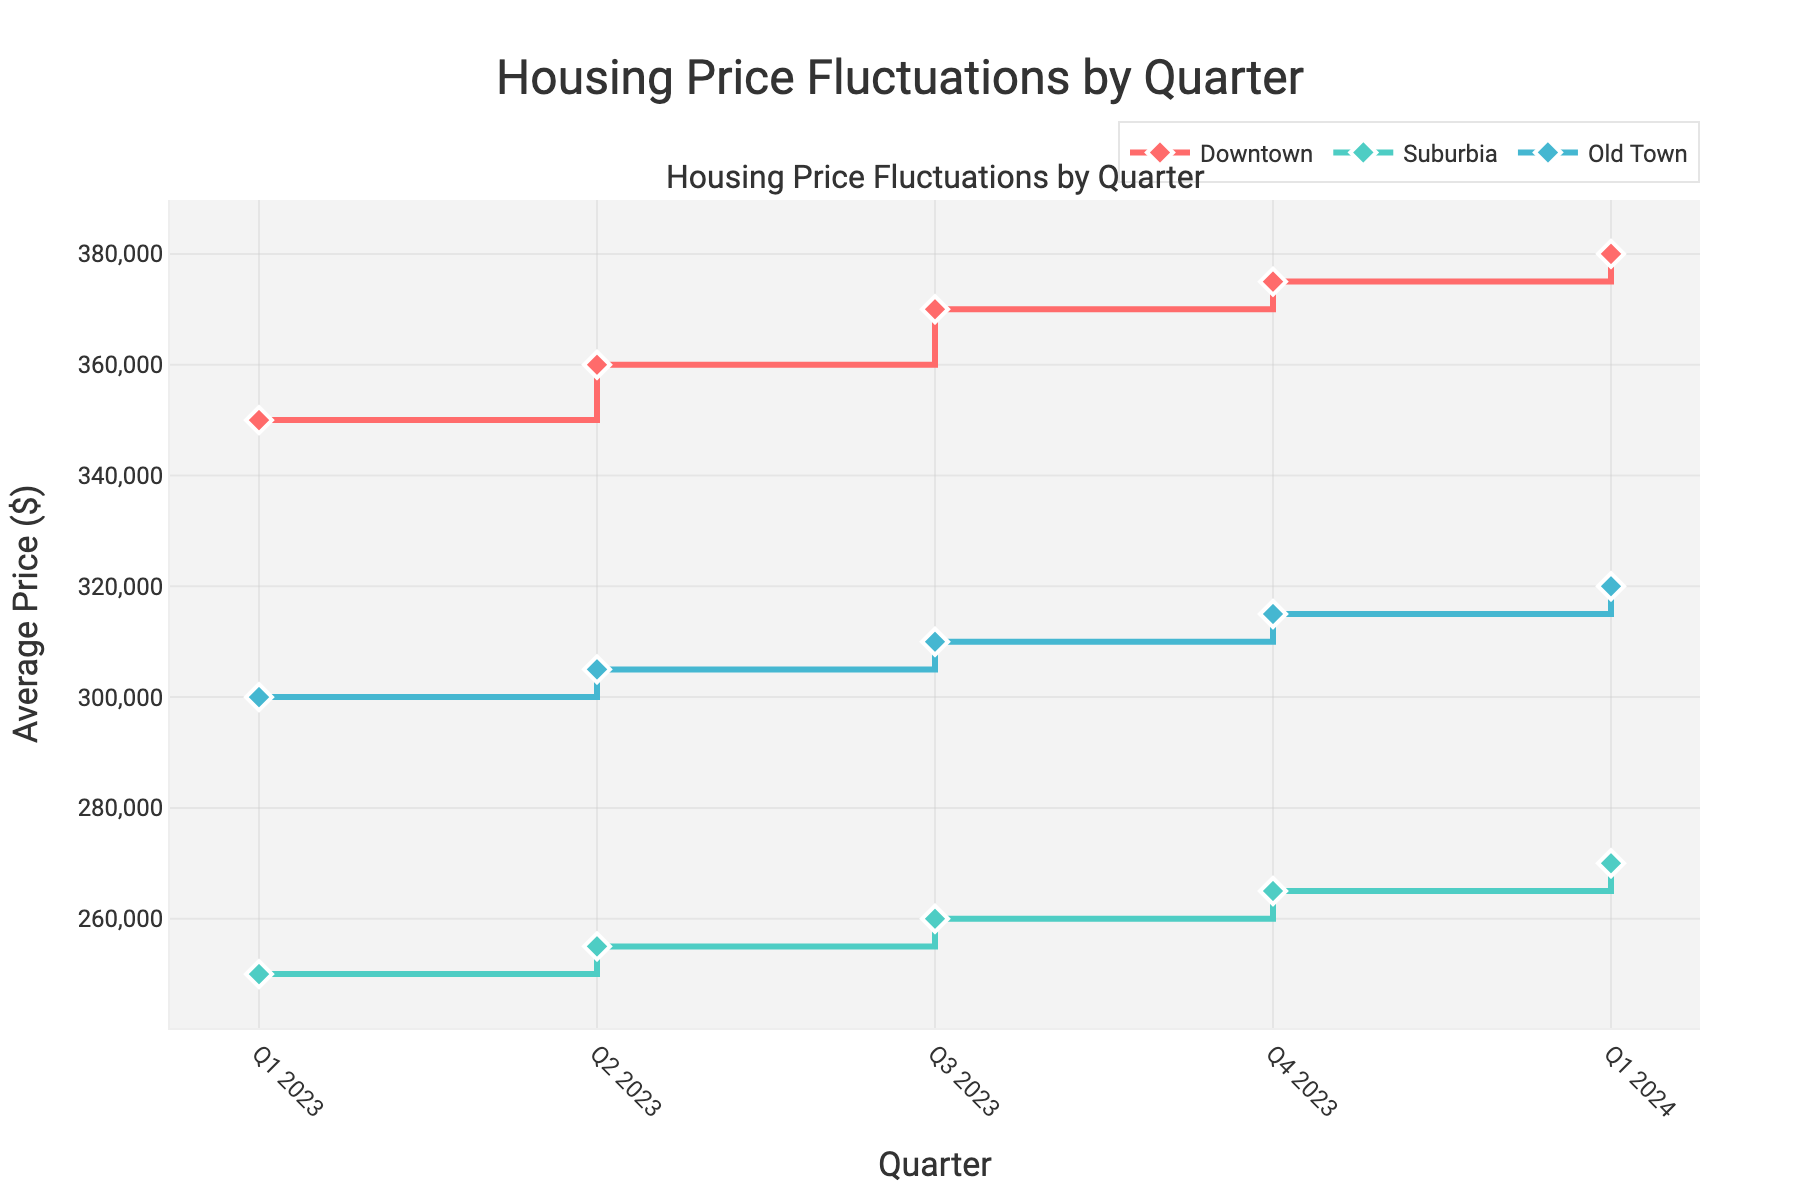What is the title of the plot? The title is displayed at the top of the plot, centered and highlighted for easy identification. The title text reads "Housing Price Fluctuations by Quarter."
Answer: Housing Price Fluctuations by Quarter What are the neighborhoods represented in the plot? The plot uses different lines and markers to represent distinct neighborhoods. The legend at the top of the plot identifies the neighborhoods by their colors and patterns. The neighborhoods are Downtown, Suburbia, and Old Town.
Answer: Downtown, Suburbia, Old Town What is the average housing price in Downtown in Q1 2023? Locate the line corresponding to Downtown and find the data point for Q1 2023. The y-axis value at that point represents the average housing price. For Downtown in Q1 2023, the average price is shown as $350,000.
Answer: $350,000 How did the average price in Suburbia change from Q1 2023 to Q4 2023? Observe the Suburbia line from Q1 2023 to Q4 2023. The y-axis values indicate the prices. Suburbia's average price increased from $250,000 in Q1 2023 to $265,000 in Q4 2023. The change is $265,000 - $250,000.
Answer: $15,000 increase Which neighborhood experienced the highest average price increase from Q1 2023 to Q1 2024? Compare the lines for Downtown, Suburbia, and Old Town over the quarters. Calculate the difference from Q1 2023 to Q1 2024 for each: Downtown ($380,000 - $350,000 = $30,000), Suburbia ($270,000 - $250,000 = $20,000), and Old Town ($320,000 - $300,000 = $20,000). The highest increase is for Downtown.
Answer: Downtown What is the average price of housing in Old Town by Q4 2023? Identify the Old Town line and follow it to the data point at Q4 2023. The y-axis value for Q4 2023 represents the average price in Old Town. It shows $315,000.
Answer: $315,000 Compare the trends in average prices for Downtown and Old Town from Q1 2023 to Q1 2024. Analyze the lines for Downtown and Old Town from Q1 2023 to Q1 2024. Both lines show an upward trend; however, Downtown's increase ($380,000 - $350,000 = $30,000) is more pronounced than Old Town's ($320,000 - $300,000 = $20,000).
Answer: Downtown increased more than Old Town What is the total average price for Suburbia from Q1 2023 to Q1 2024? Add the y-axis values for Suburbia from Q1 2023 ($250,000), Q2 2023 ($255,000), Q3 2023 ($260,000), Q4 2023 ($265,000), and Q1 2024 ($270,000): $250,000 + $255,000 + $260,000 + $265,000 + $270,000.
Answer: $1,300,000 Which quarter saw the maximum price in Downtown? Examine the Downtown line and find the peak value. The highest y-axis value appears in Q1 2024, where it touches $380,000.
Answer: Q1 2024 Between Q2 2023 and Q3 2023, which neighborhood saw the smallest price change? Check the lines between Q2 2023 and Q3 2023 for Downtown, Suburbia, and Old Town. Calculate the differences: Downtown ($370,000 - $360,000 = $10,000), Suburbia ($260,000 - $255,000 = $5,000), and Old Town ($310,000 - $305,000 = $5,000). Suburbia and Old Town both saw the smallest change.
Answer: Suburbia and Old Town 